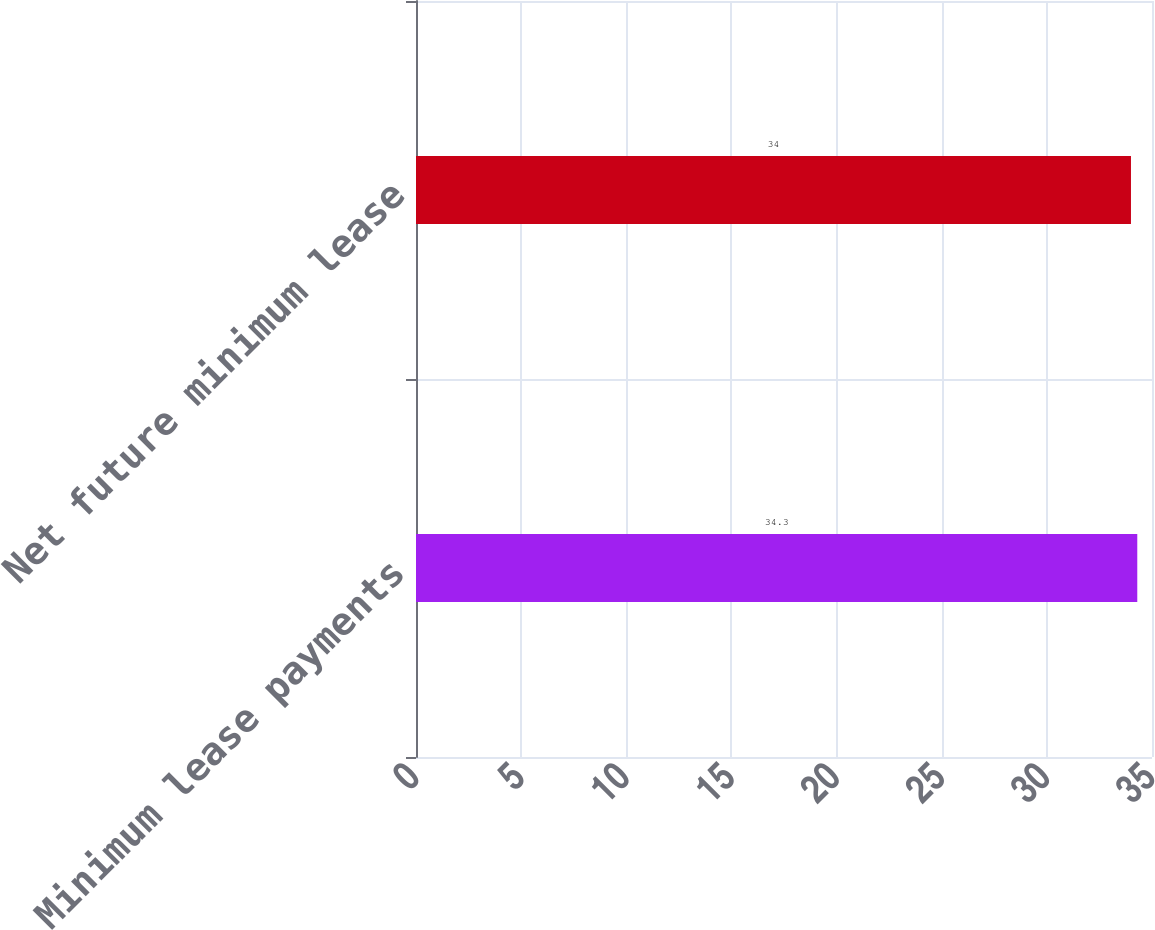<chart> <loc_0><loc_0><loc_500><loc_500><bar_chart><fcel>Minimum lease payments<fcel>Net future minimum lease<nl><fcel>34.3<fcel>34<nl></chart> 